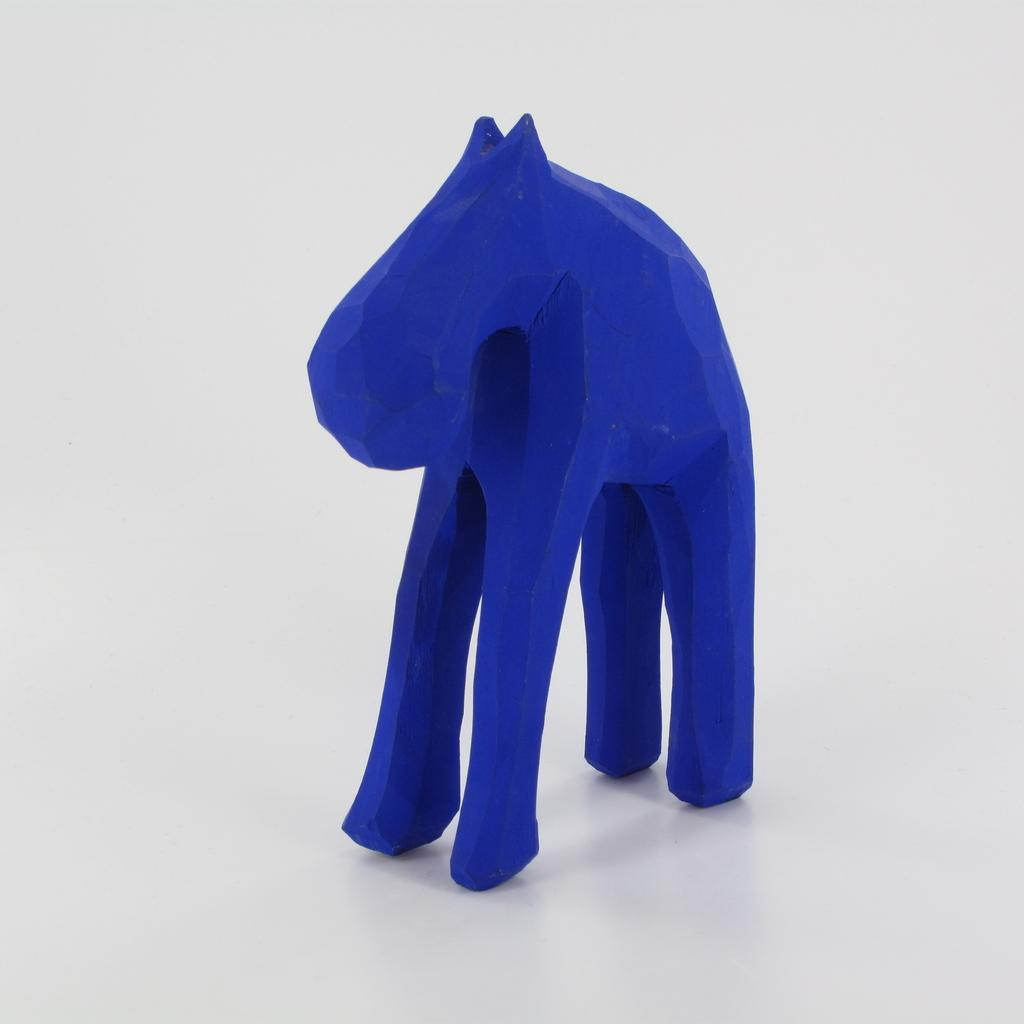What is the main subject of the image? There is an object in the middle of the image. Can you describe the color of the object? The object is blue in color. Can you tell me how many snails are crawling on the blue object in the image? There are no snails present in the image; it only features a blue object. What type of paint is used to color the blue object in the image? The image does not provide information about the type of paint used on the blue object. 